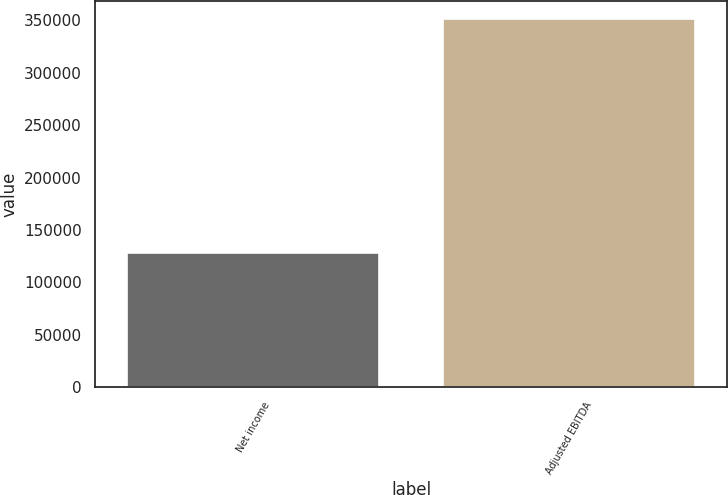Convert chart. <chart><loc_0><loc_0><loc_500><loc_500><bar_chart><fcel>Net income<fcel>Adjusted EBITDA<nl><fcel>128237<fcel>351071<nl></chart> 